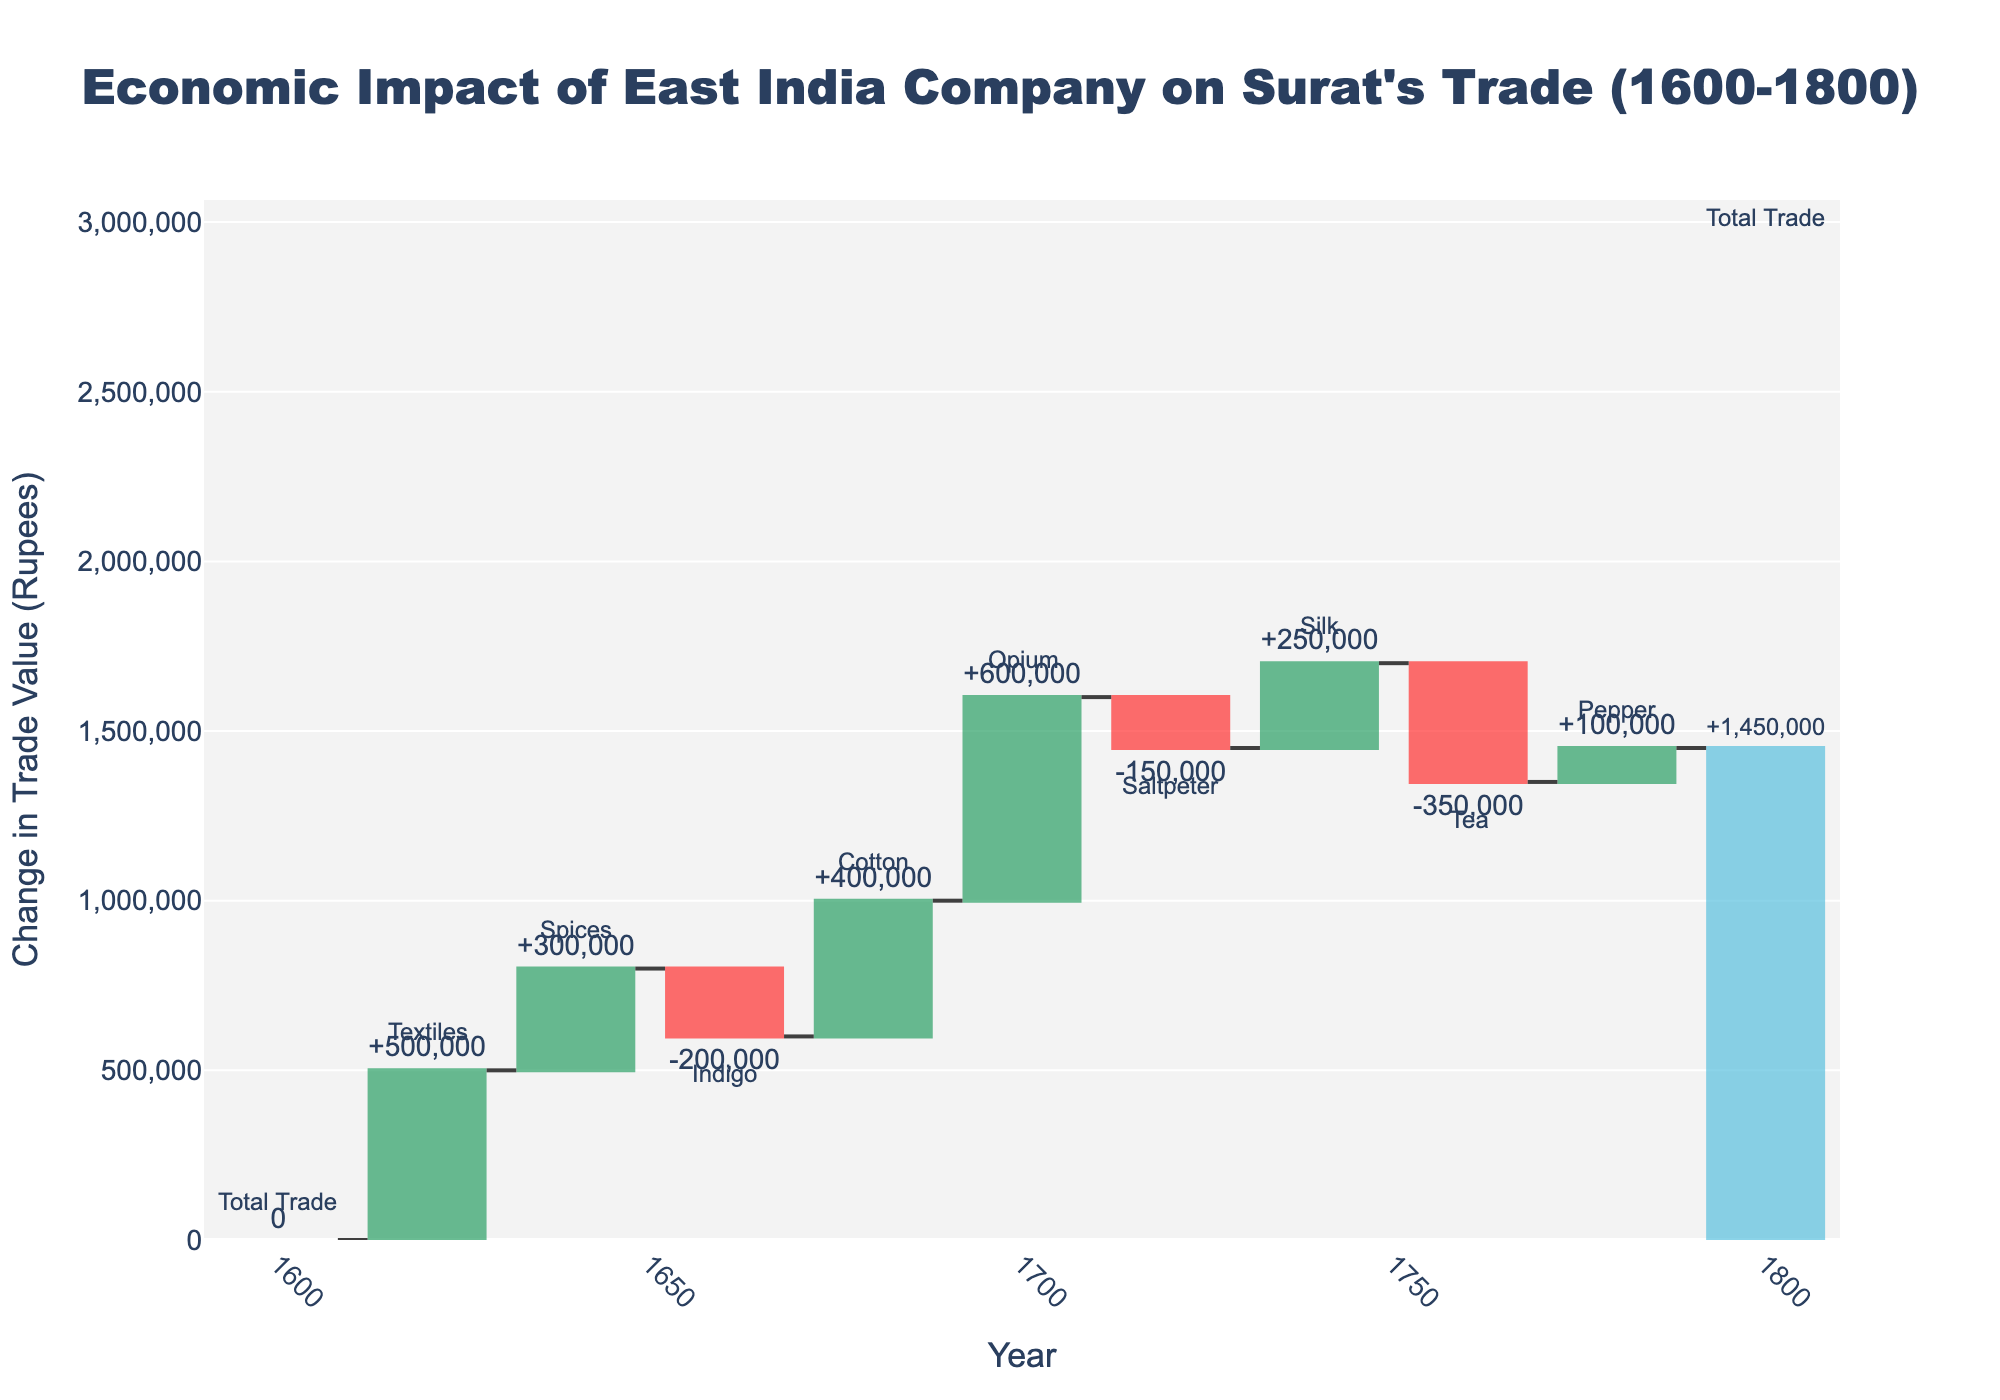What is the title of the waterfall chart? The title is always positioned at the top of the figure. In this case, it reads "Economic Impact of East India Company on Surat's Trade (1600-1800)."
Answer: Economic Impact of East India Company on Surat's Trade (1600-1800) What was the initial and final total trade value in Rupees? The chart shows the Total Trade in 1600 as 0 Rupees and the final Total Trade in 1800 as 1,450,000 Rupees.
Answer: 0 Rupees and 1,450,000 Rupees Which commodity had the most positive impact on Surat's trade value? The commodity associated with the largest positive bar segment represents the biggest positive impact. The biggest increase is seen with Opium at +600,000 Rupees around 1700.
Answer: Opium Which commodities had a negative impact on Surat's trade value? To identify negative impacts, look for bar segments that extend downward. Indigo, Saltpeter, and Tea all show negative values.
Answer: Indigo, Saltpeter, and Tea What is the trade value change attributed to Textiles around the year 1620? For this, locate the first increase after the initial point at 1600. The Textiles change is shown around 1620 with a value of +500,000 Rupees.
Answer: +500,000 Rupees Between which years did Cotton have an impact on the trade value? The impact of Cotton can be pinpointed by looking at the year labels. Cotton's impact is visible in 1680 with a +400,000 Rupees change.
Answer: 1680 Calculate the cumulative trade impact up to the year 1700. To find the cumulative trade impact, sum the changes up to and including 1700: 0 (initial) + 500,000 (Textiles) + 300,000 (Spices) - 200,000 (Indigo) + 400,000 (Cotton) + 600,000 (Opium) = 1,600,000 Rupees. However, it's important to consider how the chart might take interim totals; the chart indicates a cumulative total close to this value.
Answer: 1,600,000 Rupees Which commodity shows a positive change in trade value for the earliest recorded year? Identify the earliest year that shows a positive change in trade value by looking at the bars with positive values. The first positive change is for Textiles in 1620.
Answer: Textiles What was the net change in trade value due to Silk? Locate the point where Silk is recorded. The chart shows a positive change of +250,000 Rupees around 1740.
Answer: +250,000 Rupees What was the impact of Tea on the trade value, and when did it occur? Find the bar segment related to Tea, which is labeled around 1760, and observe the change. The change is shown as -350,000 Rupees.
Answer: -350,000 Rupees 